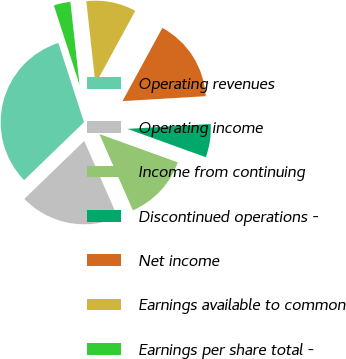<chart> <loc_0><loc_0><loc_500><loc_500><pie_chart><fcel>Operating revenues<fcel>Operating income<fcel>Income from continuing<fcel>Discontinued operations -<fcel>Net income<fcel>Earnings available to common<fcel>Earnings per share total -<nl><fcel>32.26%<fcel>19.35%<fcel>12.9%<fcel>6.45%<fcel>16.13%<fcel>9.68%<fcel>3.23%<nl></chart> 